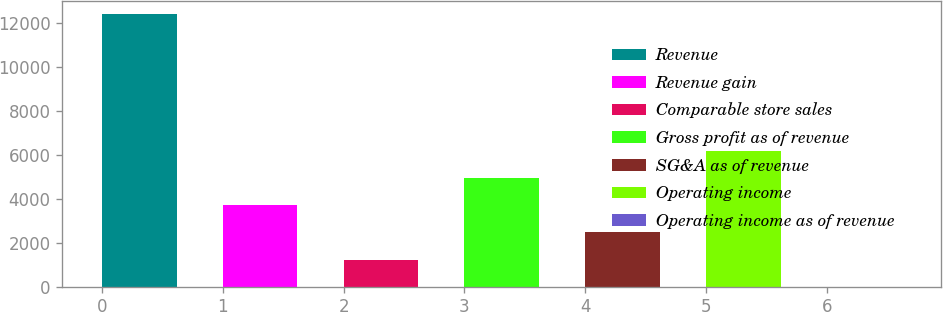<chart> <loc_0><loc_0><loc_500><loc_500><bar_chart><fcel>Revenue<fcel>Revenue gain<fcel>Comparable store sales<fcel>Gross profit as of revenue<fcel>SG&A as of revenue<fcel>Operating income<fcel>Operating income as of revenue<nl><fcel>12380<fcel>3714.91<fcel>1239.17<fcel>4952.78<fcel>2477.04<fcel>6190.65<fcel>1.3<nl></chart> 